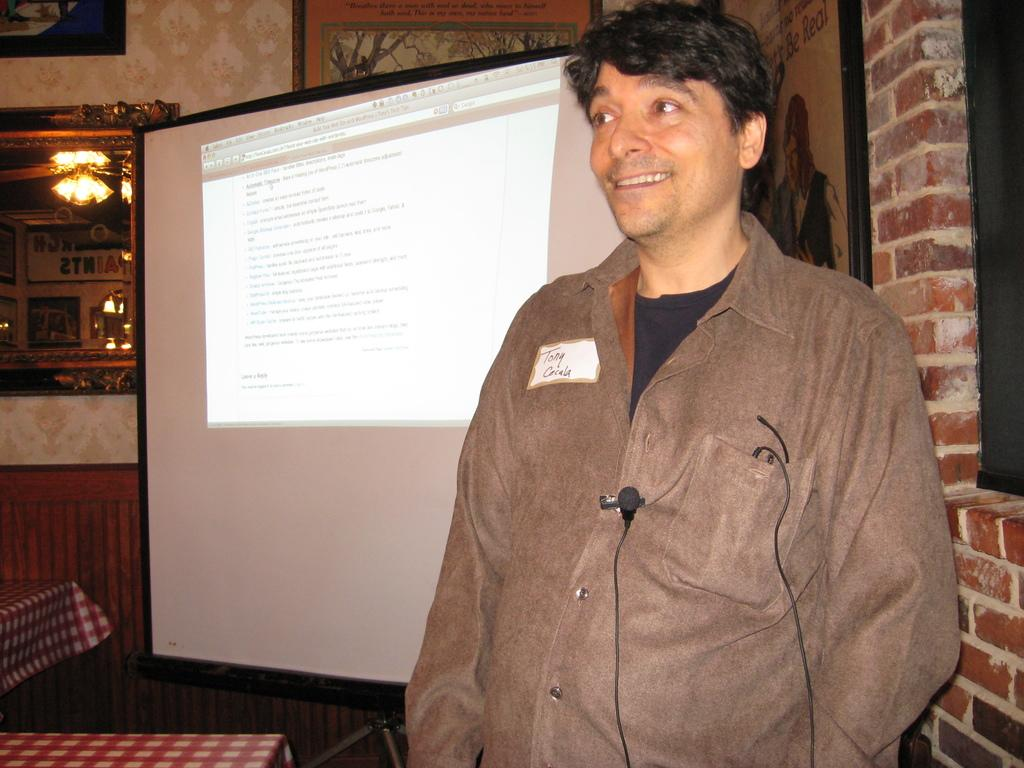What is the person in the image doing? There is a person standing in the image. What can be seen attached to the person's t-shirt? The person has a mic attached to their t-shirt. What equipment is present in the image for displaying visuals? There is a projector screen on a stand in the image. What is on the wall in the image? There is a mirror on the wall in the image. What type of sweater is the farmer wearing in the alley in the image? There is no farmer or alley present in the image, and the person in the image is not wearing a sweater. 